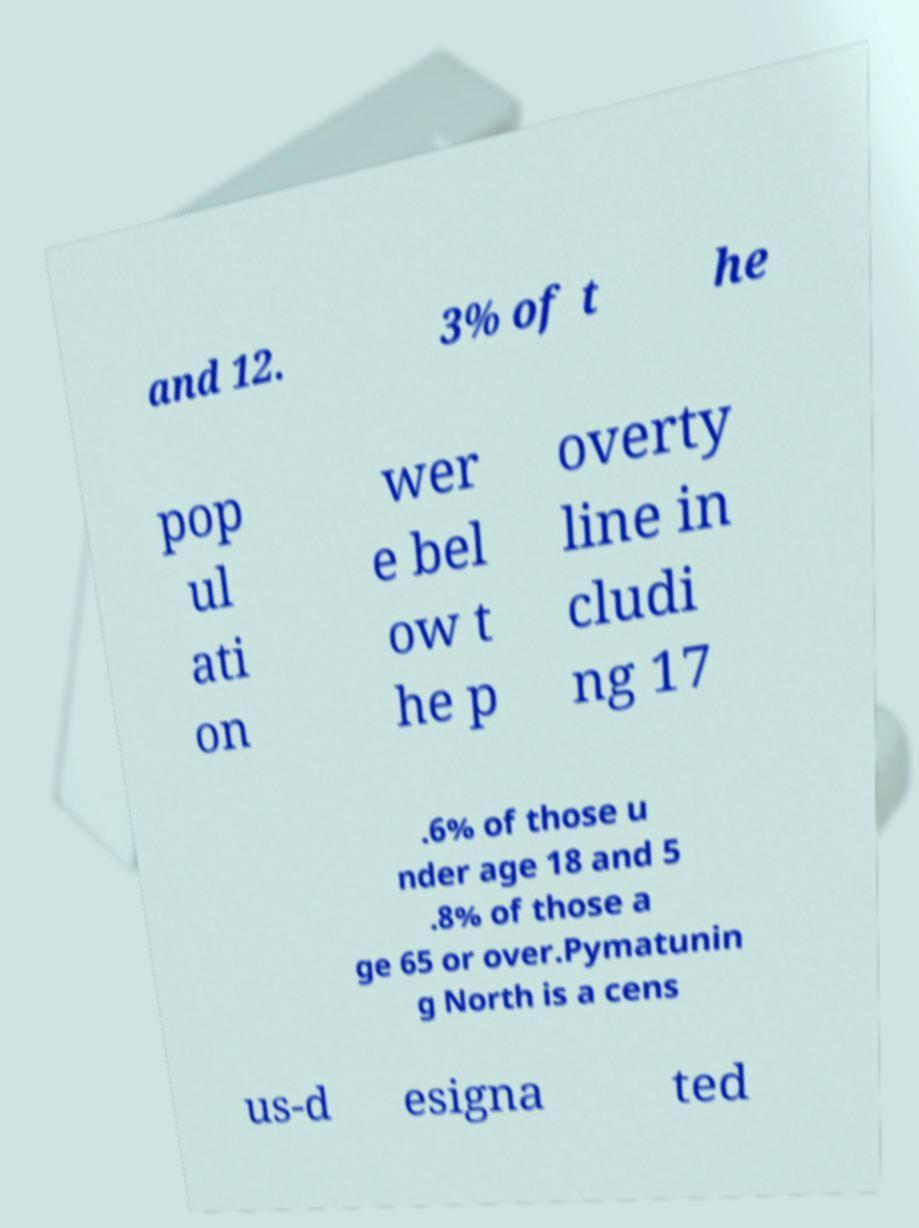Please read and relay the text visible in this image. What does it say? and 12. 3% of t he pop ul ati on wer e bel ow t he p overty line in cludi ng 17 .6% of those u nder age 18 and 5 .8% of those a ge 65 or over.Pymatunin g North is a cens us-d esigna ted 